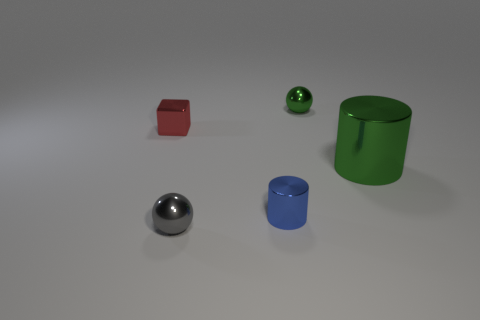Does the metallic block have the same color as the small metallic cylinder? The metallic block has a distinct red color, whereas the small metallic cylinder appears to be green. The two objects exhibit different hues and are not the same color. 